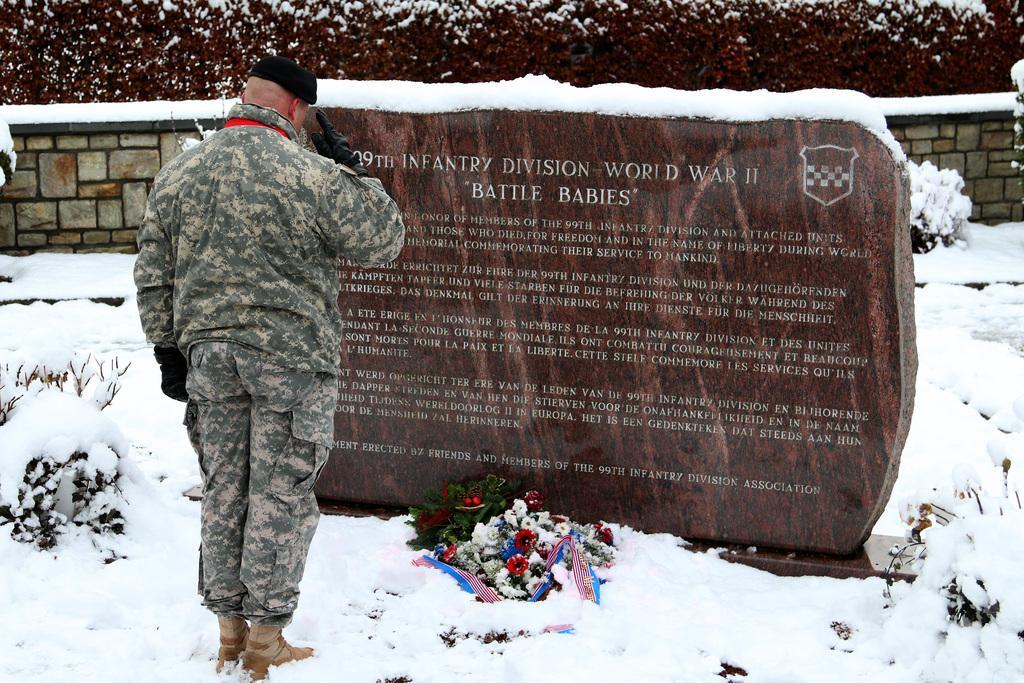Please provide a concise description of this image. In this image there is an army person standing in front of a memorial stone with some text engraved on it. In front of the stone there is a flower bouquet. At the bottom of the image there is snow on the surface. There are plants. In the background of the image there is a wall. There are trees. 